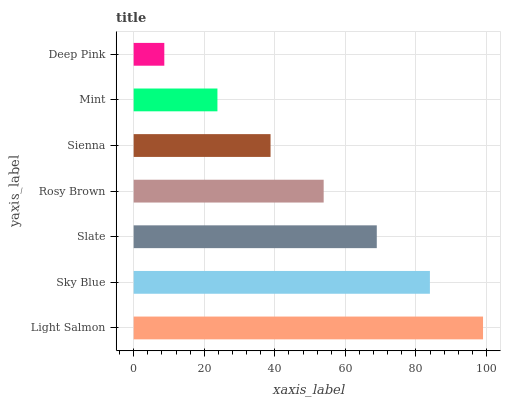Is Deep Pink the minimum?
Answer yes or no. Yes. Is Light Salmon the maximum?
Answer yes or no. Yes. Is Sky Blue the minimum?
Answer yes or no. No. Is Sky Blue the maximum?
Answer yes or no. No. Is Light Salmon greater than Sky Blue?
Answer yes or no. Yes. Is Sky Blue less than Light Salmon?
Answer yes or no. Yes. Is Sky Blue greater than Light Salmon?
Answer yes or no. No. Is Light Salmon less than Sky Blue?
Answer yes or no. No. Is Rosy Brown the high median?
Answer yes or no. Yes. Is Rosy Brown the low median?
Answer yes or no. Yes. Is Slate the high median?
Answer yes or no. No. Is Sienna the low median?
Answer yes or no. No. 